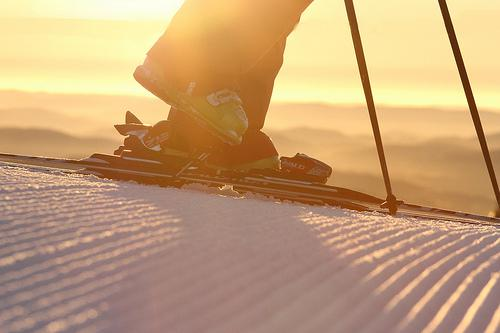Question: what activity is depicted?
Choices:
A. Running.
B. Swimming.
C. Hockey.
D. Skiing.
Answer with the letter. Answer: D Question: where was the photo taken?
Choices:
A. On a ski slope.
B. Mountain.
C. Outside.
D. On beach.
Answer with the letter. Answer: A Question: what pattern is on the snow?
Choices:
A. Lumps.
B. Feet.
C. Lines.
D. Dog feet.
Answer with the letter. Answer: C Question: when was the photo taken?
Choices:
A. Night.
B. Evening.
C. Morning.
D. During the day.
Answer with the letter. Answer: D Question: what is the bright light in the picture?
Choices:
A. Flash.
B. Glasses.
C. The sun.
D. Glare.
Answer with the letter. Answer: C 